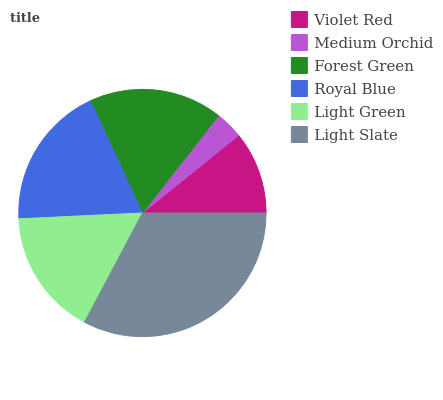Is Medium Orchid the minimum?
Answer yes or no. Yes. Is Light Slate the maximum?
Answer yes or no. Yes. Is Forest Green the minimum?
Answer yes or no. No. Is Forest Green the maximum?
Answer yes or no. No. Is Forest Green greater than Medium Orchid?
Answer yes or no. Yes. Is Medium Orchid less than Forest Green?
Answer yes or no. Yes. Is Medium Orchid greater than Forest Green?
Answer yes or no. No. Is Forest Green less than Medium Orchid?
Answer yes or no. No. Is Forest Green the high median?
Answer yes or no. Yes. Is Light Green the low median?
Answer yes or no. Yes. Is Light Slate the high median?
Answer yes or no. No. Is Forest Green the low median?
Answer yes or no. No. 